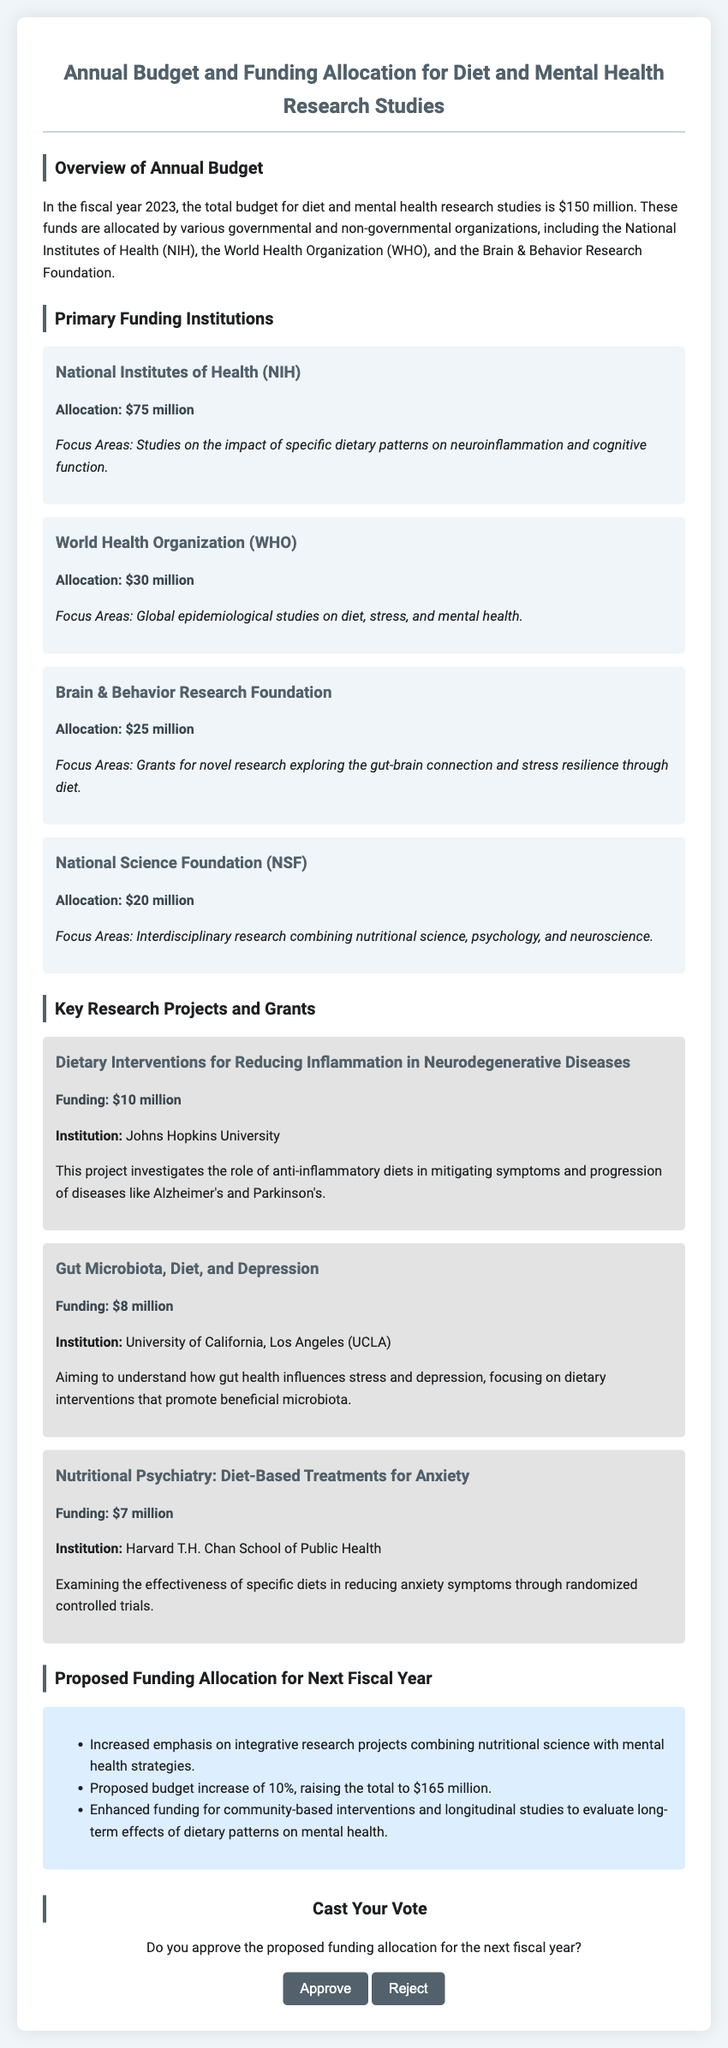What is the total budget for diet and mental health research studies in 2023? The total budget mentioned in the document for the fiscal year 2023 is $150 million.
Answer: $150 million Which organization received the highest funding allocation? The document states that the National Institutes of Health (NIH) received the highest funding allocation of $75 million.
Answer: National Institutes of Health (NIH) How much funding is allocated to the World Health Organization (WHO)? According to the document, the World Health Organization (WHO) has an allocation of $30 million.
Answer: $30 million What is the focus area of the funding from the Brain & Behavior Research Foundation? The document mentions that the focus area for the Brain & Behavior Research Foundation is grants for novel research exploring the gut-brain connection and stress resilience through diet.
Answer: Gut-brain connection and stress resilience through diet What is the proposed budget increase for the next fiscal year? The document states that there is a proposed budget increase of 10%, which would raise the total to $165 million.
Answer: 10% What is the funding amount for the project titled "Gut Microbiota, Diet, and Depression"? According to the document, the project "Gut Microbiota, Diet, and Depression" has a funding allocation of $8 million.
Answer: $8 million Which institution is associated with the project on dietary interventions for reducing inflammation in neurodegenerative diseases? The document lists Johns Hopkins University as the institution associated with this project.
Answer: Johns Hopkins University What is the proposed emphasis for research projects in the next fiscal year? The document suggests that there will be an increased emphasis on integrative research projects combining nutritional science with mental health strategies.
Answer: Integrative research projects combining nutritional science with mental health strategies Do the proposed funding allocations require approval? The document poses a question asking if the reader approves the proposed funding allocation for the next fiscal year, indicating approval is required.
Answer: Yes 